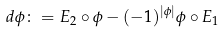Convert formula to latex. <formula><loc_0><loc_0><loc_500><loc_500>d \phi \colon = E _ { 2 } \circ \phi - ( - 1 ) ^ { | \phi | } \phi \circ E _ { 1 }</formula> 